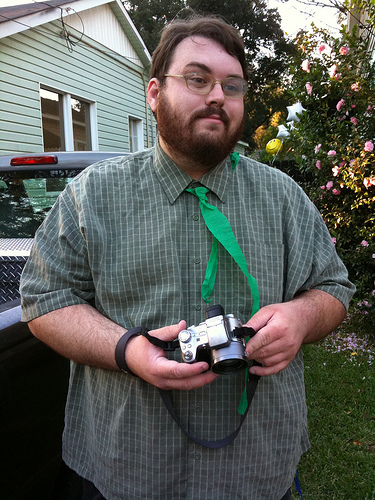Describe the setting where the man is. The man is outdoors, standing in front of a green residential building with a well-tended rose bush nearby. A pickup truck is partially visible to the left of the frame. What time of day does it appear to be? Given the soft shadows and warm lighting, it seems to be late afternoon or early evening. 